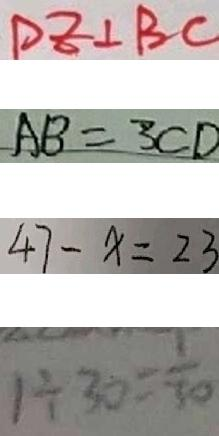Convert formula to latex. <formula><loc_0><loc_0><loc_500><loc_500>D E \bot B C 
 A B = 3 C D 
 4 7 - x = 2 3 
 1 \div 3 0 = \frac { 1 } { 3 0 }</formula> 